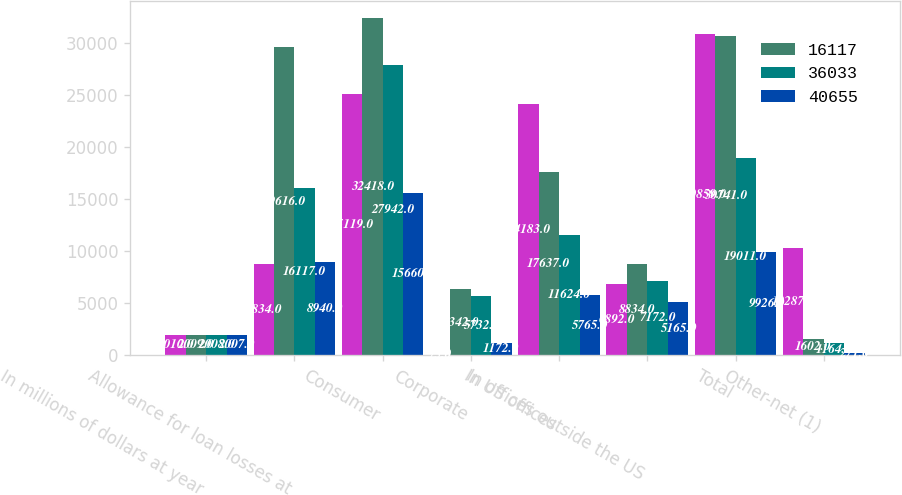Convert chart to OTSL. <chart><loc_0><loc_0><loc_500><loc_500><stacked_bar_chart><ecel><fcel>In millions of dollars at year<fcel>Allowance for loan losses at<fcel>Consumer<fcel>Corporate<fcel>In US offices<fcel>In offices outside the US<fcel>Total<fcel>Other-net (1)<nl><fcel>nan<fcel>2010<fcel>8834<fcel>25119<fcel>75<fcel>24183<fcel>6892<fcel>30859<fcel>10287<nl><fcel>16117<fcel>2009<fcel>29616<fcel>32418<fcel>6342<fcel>17637<fcel>8834<fcel>30741<fcel>1602<nl><fcel>36033<fcel>2008<fcel>16117<fcel>27942<fcel>5732<fcel>11624<fcel>7172<fcel>19011<fcel>1164<nl><fcel>40655<fcel>2007<fcel>8940<fcel>15660<fcel>1172<fcel>5765<fcel>5165<fcel>9926<fcel>271<nl></chart> 